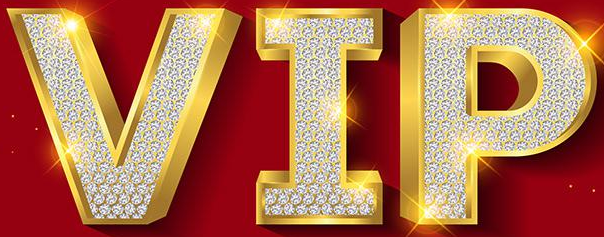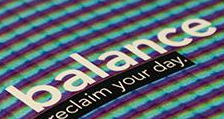What words are shown in these images in order, separated by a semicolon? VIP; balance 